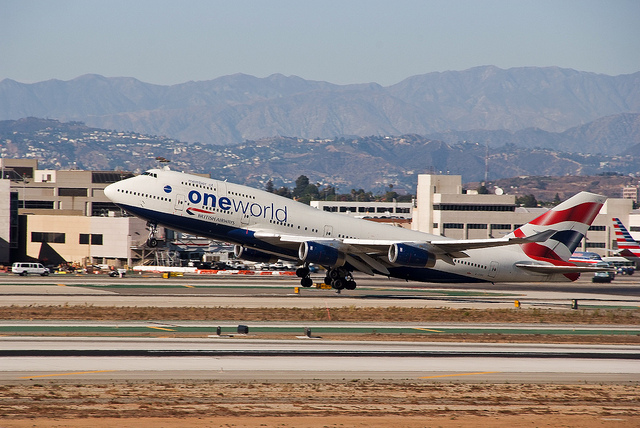Can you tell what alliance the airline is a part of? Yes, the livery on the airplane includes the 'one world' alliance logo, indicating that the airline is part of the 'one world' airline alliance. 